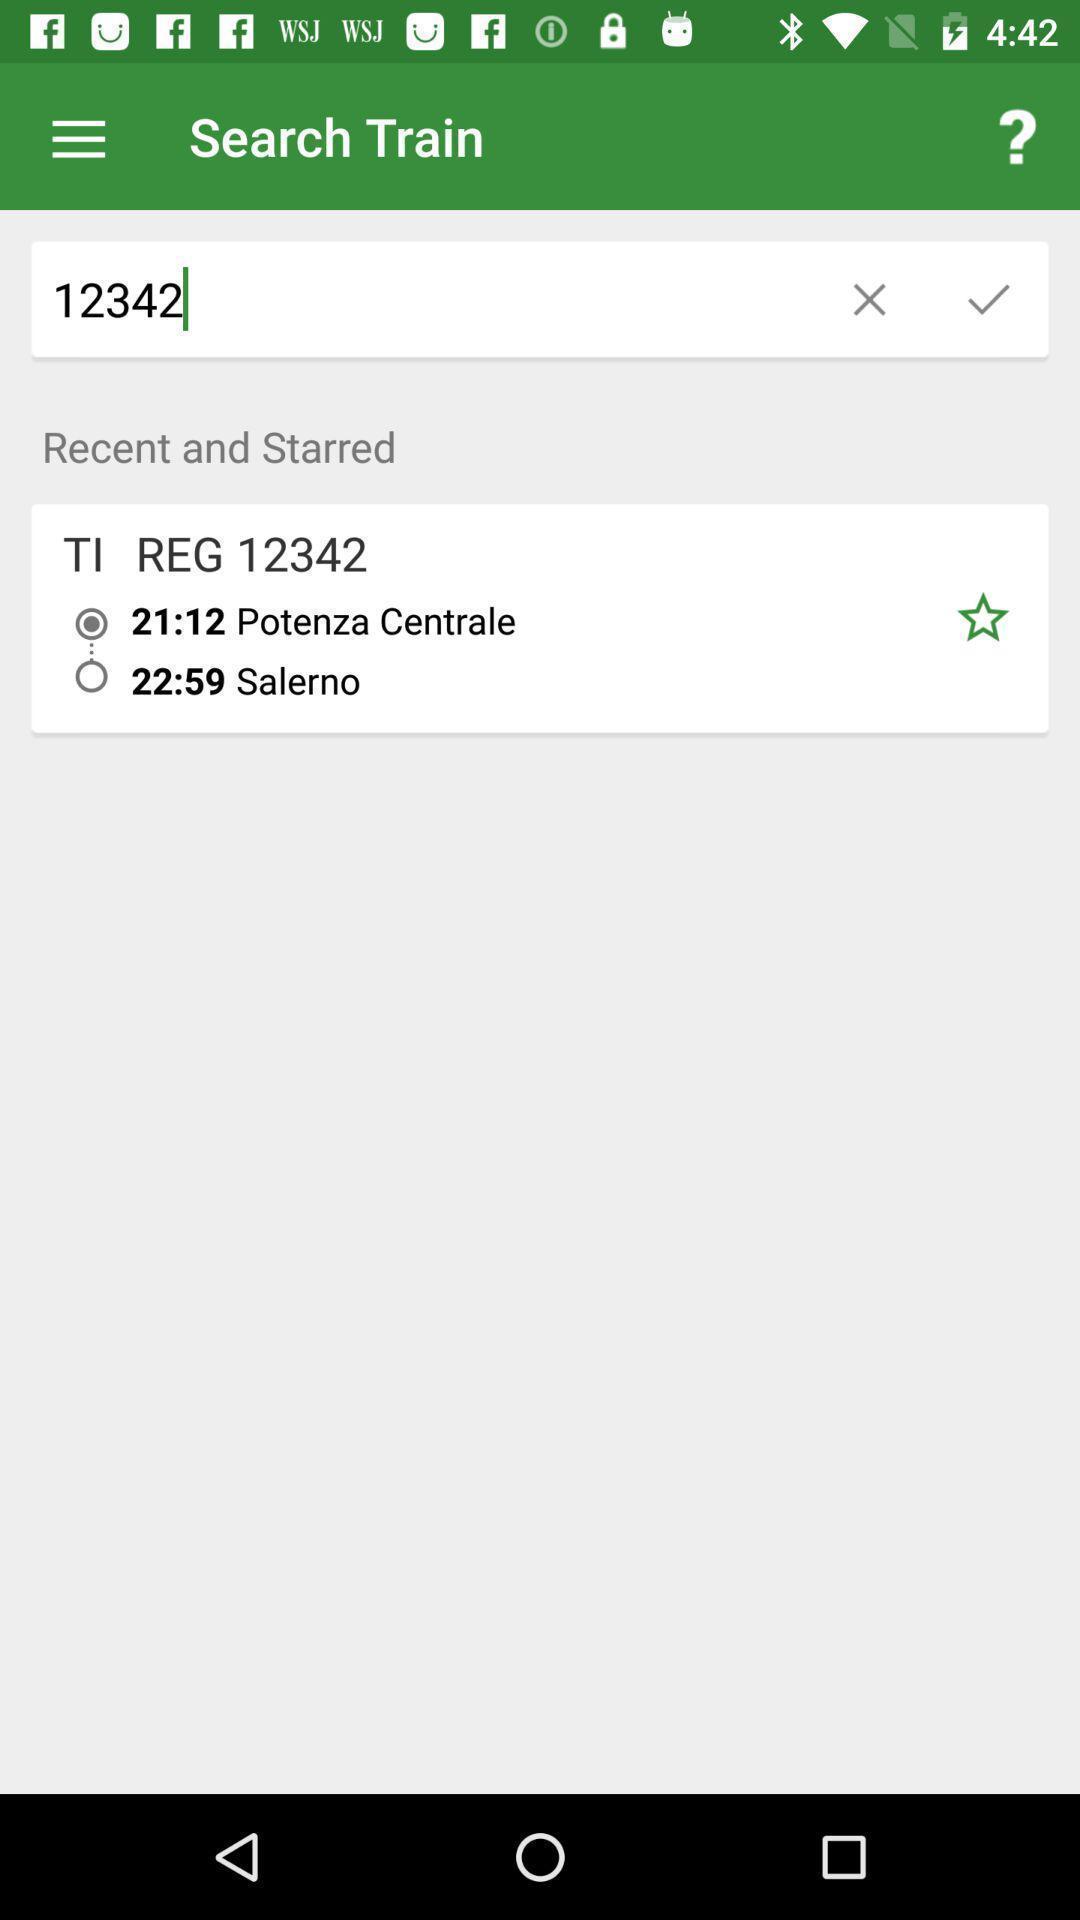Give me a narrative description of this picture. Search train page of a train app. 